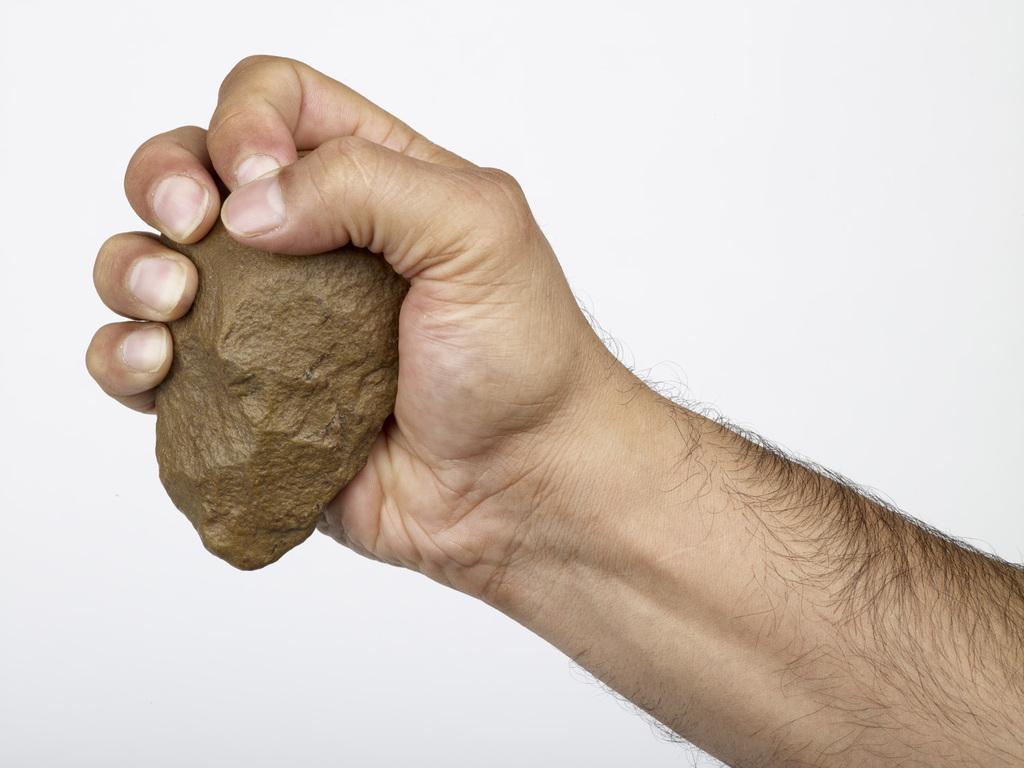Can you describe this image briefly? In this image, we can see the hand of a person holding an object. There is a white background. 